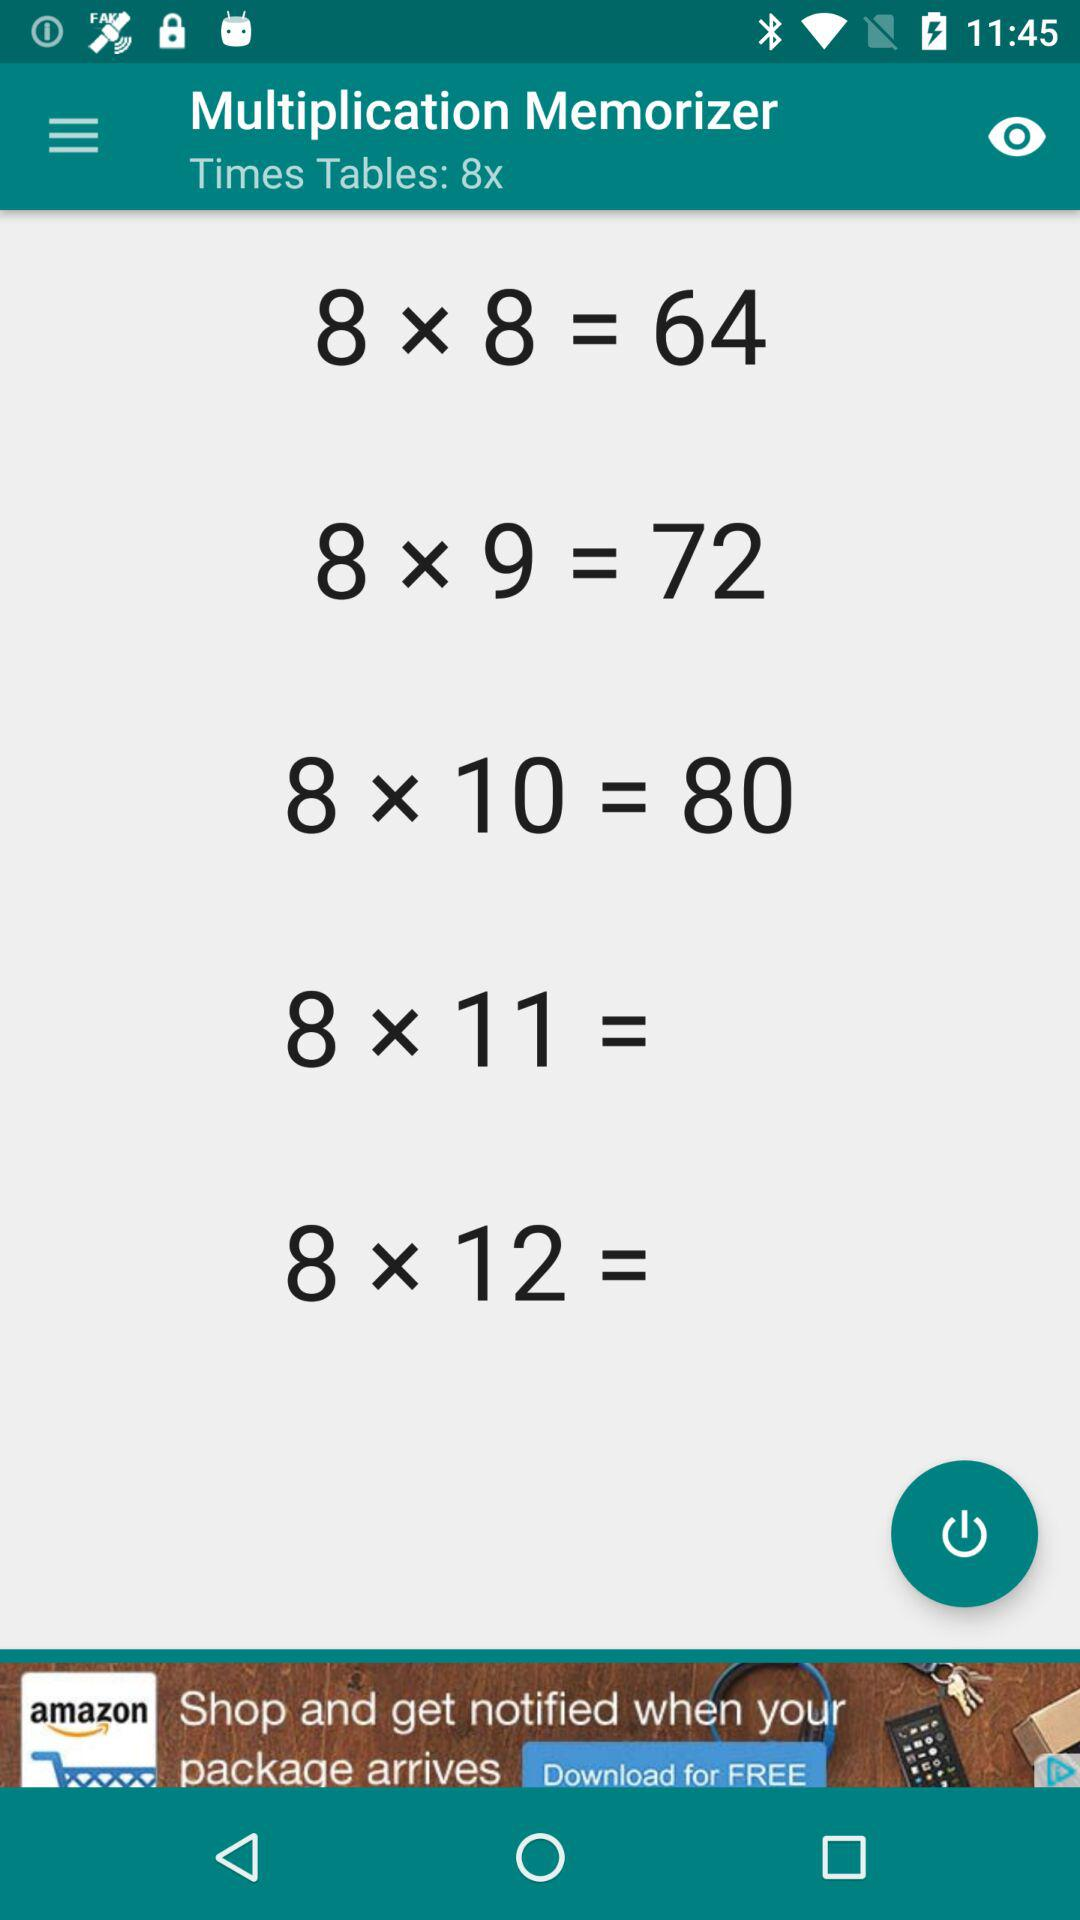What is the result of 8*8? The result of 8*8 is 64. 